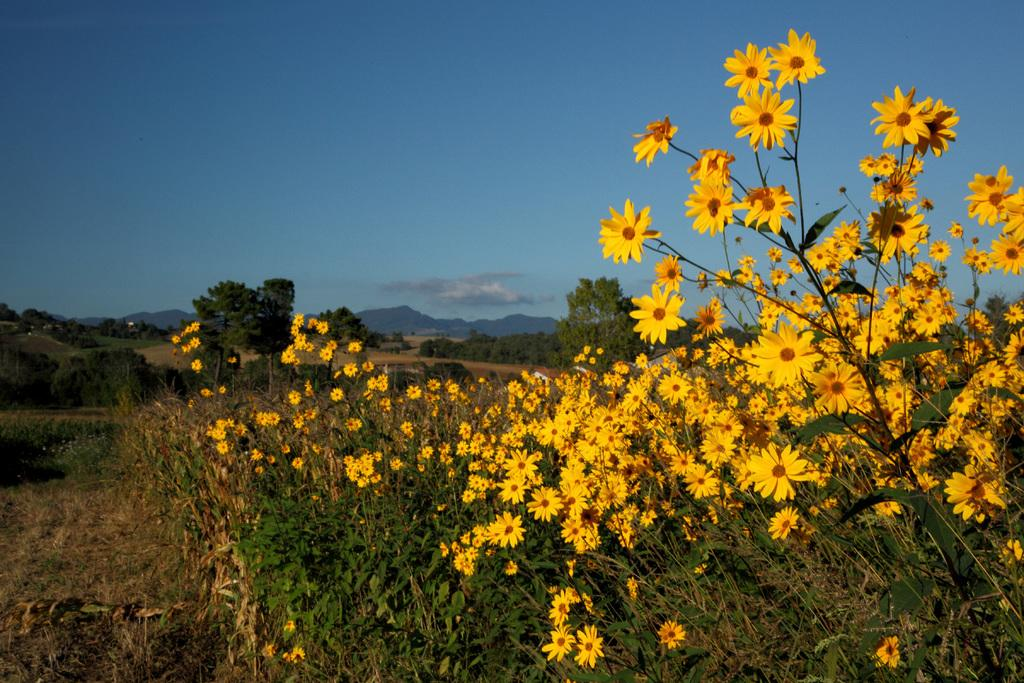What type of plants are present in the image? There are plants with yellow flowers in the image. What can be seen in the background of the image? There are trees, mountains, and clouds in the sky in the background of the image. What type of net is being used to catch the ball in the image? There is no ball or net present in the image; it features plants with yellow flowers and a background with trees, mountains, and clouds. 